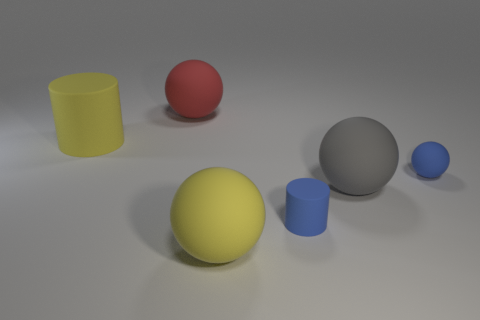Is there anything else that has the same size as the blue rubber ball?
Offer a very short reply. Yes. The red thing that is the same material as the tiny blue sphere is what shape?
Make the answer very short. Sphere. Is there anything else that has the same shape as the large red object?
Your answer should be compact. Yes. How many tiny blue matte cylinders are behind the large cylinder?
Make the answer very short. 0. Are any large green matte blocks visible?
Give a very brief answer. No. There is a large rubber ball to the right of the matte cylinder that is in front of the object that is to the left of the big red object; what is its color?
Offer a very short reply. Gray. There is a tiny matte object that is right of the large gray ball; is there a yellow object that is behind it?
Give a very brief answer. Yes. There is a rubber cylinder in front of the large matte cylinder; is it the same color as the tiny matte thing behind the large gray matte thing?
Your answer should be very brief. Yes. What number of other red matte things have the same size as the red matte thing?
Provide a succinct answer. 0. There is a matte cylinder right of the red rubber sphere; is it the same size as the tiny ball?
Make the answer very short. Yes. 